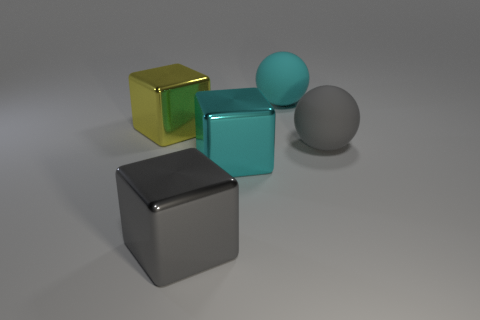Add 1 cyan balls. How many objects exist? 6 Subtract all blocks. How many objects are left? 2 Add 1 big metallic things. How many big metallic things are left? 4 Add 5 tiny brown metallic objects. How many tiny brown metallic objects exist? 5 Subtract 0 blue spheres. How many objects are left? 5 Subtract all small cyan rubber cylinders. Subtract all big cyan shiny objects. How many objects are left? 4 